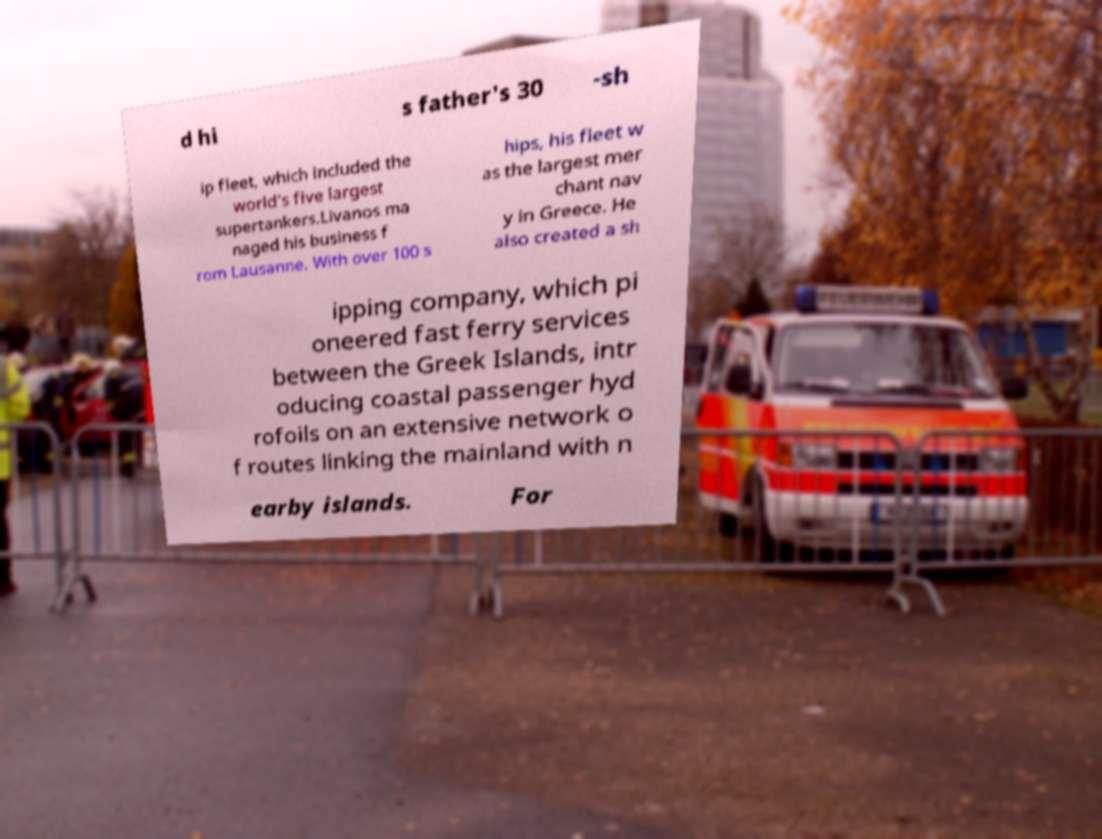What messages or text are displayed in this image? I need them in a readable, typed format. d hi s father's 30 -sh ip fleet, which included the world's five largest supertankers.Livanos ma naged his business f rom Lausanne. With over 100 s hips, his fleet w as the largest mer chant nav y in Greece. He also created a sh ipping company, which pi oneered fast ferry services between the Greek Islands, intr oducing coastal passenger hyd rofoils on an extensive network o f routes linking the mainland with n earby islands. For 